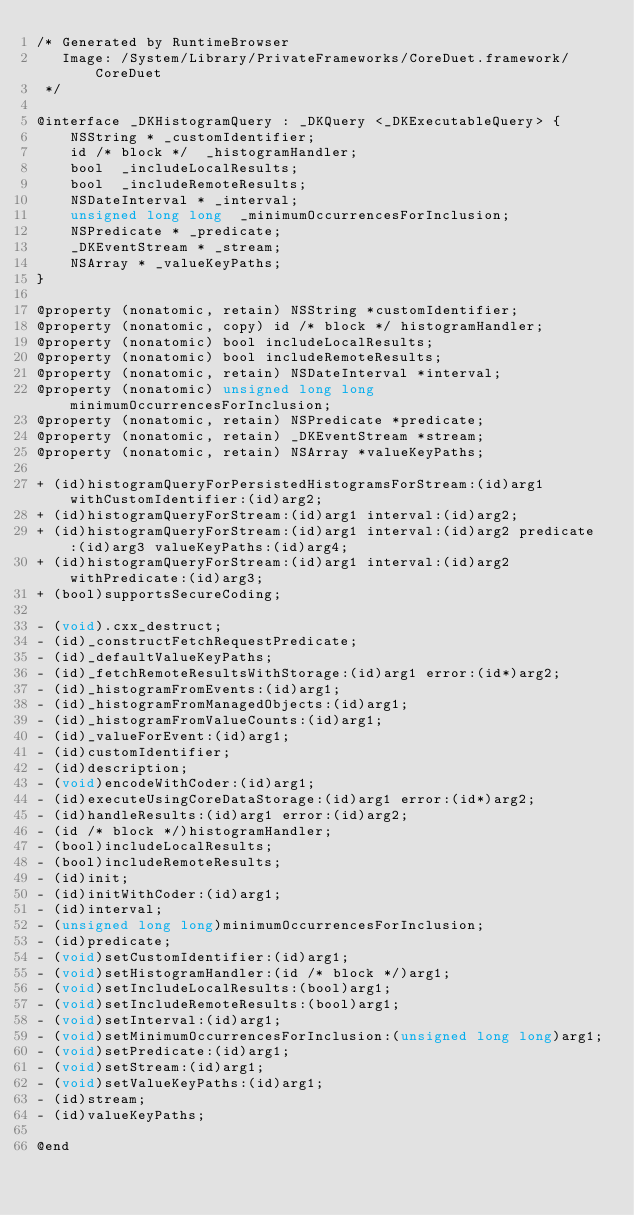<code> <loc_0><loc_0><loc_500><loc_500><_C_>/* Generated by RuntimeBrowser
   Image: /System/Library/PrivateFrameworks/CoreDuet.framework/CoreDuet
 */

@interface _DKHistogramQuery : _DKQuery <_DKExecutableQuery> {
    NSString * _customIdentifier;
    id /* block */  _histogramHandler;
    bool  _includeLocalResults;
    bool  _includeRemoteResults;
    NSDateInterval * _interval;
    unsigned long long  _minimumOccurrencesForInclusion;
    NSPredicate * _predicate;
    _DKEventStream * _stream;
    NSArray * _valueKeyPaths;
}

@property (nonatomic, retain) NSString *customIdentifier;
@property (nonatomic, copy) id /* block */ histogramHandler;
@property (nonatomic) bool includeLocalResults;
@property (nonatomic) bool includeRemoteResults;
@property (nonatomic, retain) NSDateInterval *interval;
@property (nonatomic) unsigned long long minimumOccurrencesForInclusion;
@property (nonatomic, retain) NSPredicate *predicate;
@property (nonatomic, retain) _DKEventStream *stream;
@property (nonatomic, retain) NSArray *valueKeyPaths;

+ (id)histogramQueryForPersistedHistogramsForStream:(id)arg1 withCustomIdentifier:(id)arg2;
+ (id)histogramQueryForStream:(id)arg1 interval:(id)arg2;
+ (id)histogramQueryForStream:(id)arg1 interval:(id)arg2 predicate:(id)arg3 valueKeyPaths:(id)arg4;
+ (id)histogramQueryForStream:(id)arg1 interval:(id)arg2 withPredicate:(id)arg3;
+ (bool)supportsSecureCoding;

- (void).cxx_destruct;
- (id)_constructFetchRequestPredicate;
- (id)_defaultValueKeyPaths;
- (id)_fetchRemoteResultsWithStorage:(id)arg1 error:(id*)arg2;
- (id)_histogramFromEvents:(id)arg1;
- (id)_histogramFromManagedObjects:(id)arg1;
- (id)_histogramFromValueCounts:(id)arg1;
- (id)_valueForEvent:(id)arg1;
- (id)customIdentifier;
- (id)description;
- (void)encodeWithCoder:(id)arg1;
- (id)executeUsingCoreDataStorage:(id)arg1 error:(id*)arg2;
- (id)handleResults:(id)arg1 error:(id)arg2;
- (id /* block */)histogramHandler;
- (bool)includeLocalResults;
- (bool)includeRemoteResults;
- (id)init;
- (id)initWithCoder:(id)arg1;
- (id)interval;
- (unsigned long long)minimumOccurrencesForInclusion;
- (id)predicate;
- (void)setCustomIdentifier:(id)arg1;
- (void)setHistogramHandler:(id /* block */)arg1;
- (void)setIncludeLocalResults:(bool)arg1;
- (void)setIncludeRemoteResults:(bool)arg1;
- (void)setInterval:(id)arg1;
- (void)setMinimumOccurrencesForInclusion:(unsigned long long)arg1;
- (void)setPredicate:(id)arg1;
- (void)setStream:(id)arg1;
- (void)setValueKeyPaths:(id)arg1;
- (id)stream;
- (id)valueKeyPaths;

@end
</code> 